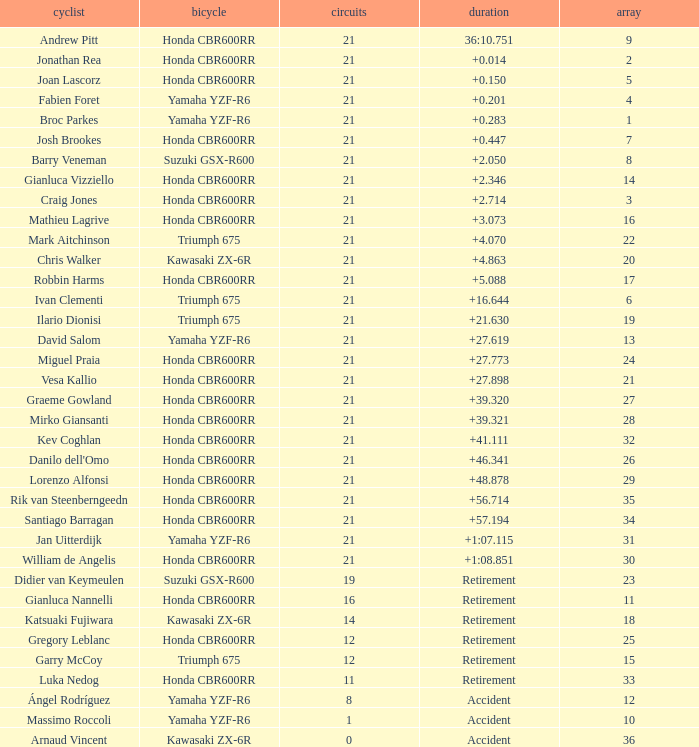What is the total of laps run by the driver with a grid under 17 and a time of +5.088? None. 